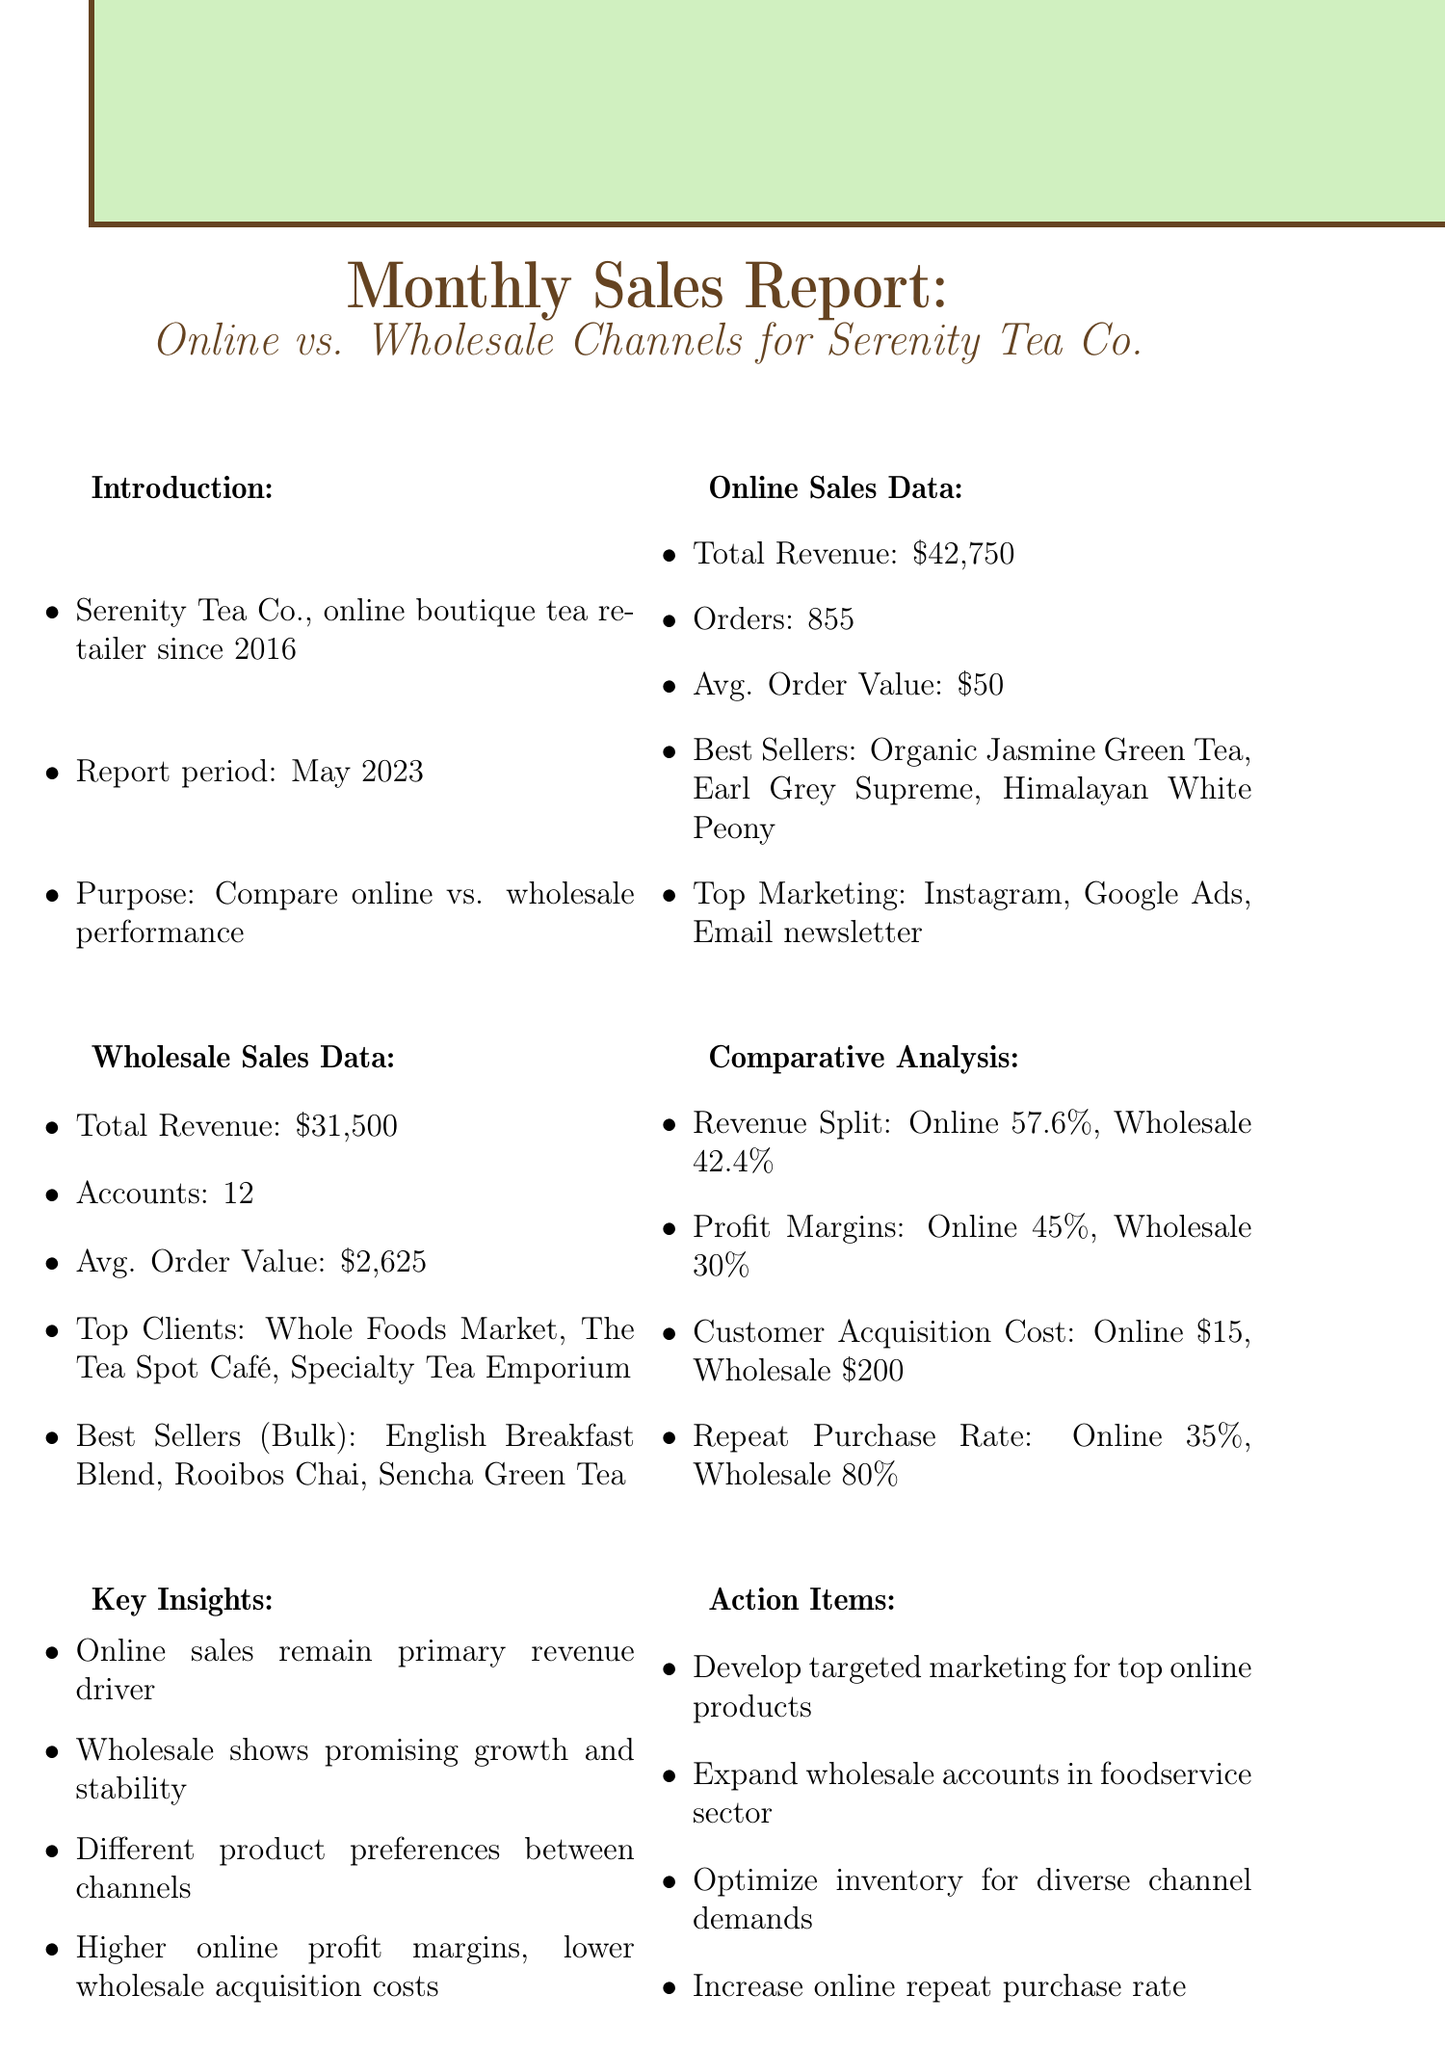What is the total revenue from online sales? The total revenue from online sales is explicitly mentioned in the online sales data section of the document.
Answer: $42,750 What was the average order value in the wholesale channel? The average order value for the wholesale channel is provided in the wholesale sales data section.
Answer: $2,625 Which platform is the top marketing channel for online sales? The document lists the top marketing channels, with Instagram being the first mentioned in the online sales data.
Answer: Instagram What percentage of total revenue comes from online sales? The revenue split between online and wholesale is given in the comparative analysis section, indicating the percentage from online sales.
Answer: 57.6% What is the repeat purchase rate for wholesale customers? The repeat purchase rate is stated in the comparative analysis section specifically for the wholesale channel.
Answer: 80% Which product is the best seller in the online sales category? The best selling products of the online sales category are detailed in the online sales data, with the first being Organic Jasmine Green Tea.
Answer: Organic Jasmine Green Tea How many accounts does the wholesale channel serve? The number of accounts for the wholesale channel is found in the wholesale sales data section.
Answer: 12 What key insight highlights online sales? One of the key insights mentions that online sales remain the primary revenue driver, as indicated in the key insights section.
Answer: Online sales remain primary revenue driver What action item aims to improve online sales? The action items include a specific plan to develop targeted marketing for top online products, which is detailed in the action items section.
Answer: Develop targeted marketing for top online products 